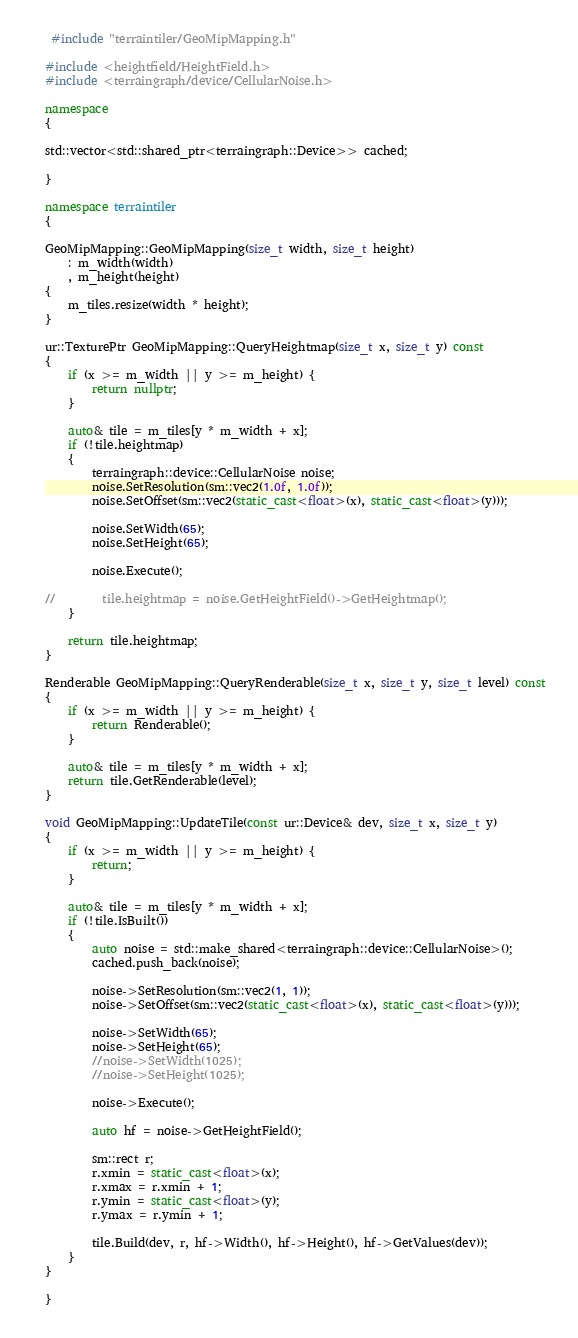<code> <loc_0><loc_0><loc_500><loc_500><_C++_> #include "terraintiler/GeoMipMapping.h"

#include <heightfield/HeightField.h>
#include <terraingraph/device/CellularNoise.h>

namespace
{

std::vector<std::shared_ptr<terraingraph::Device>> cached;

}

namespace terraintiler
{

GeoMipMapping::GeoMipMapping(size_t width, size_t height)
    : m_width(width)
    , m_height(height)
{
    m_tiles.resize(width * height);
}

ur::TexturePtr GeoMipMapping::QueryHeightmap(size_t x, size_t y) const
{
    if (x >= m_width || y >= m_height) {
        return nullptr;
    }

    auto& tile = m_tiles[y * m_width + x];
    if (!tile.heightmap)
    {
        terraingraph::device::CellularNoise noise;
        noise.SetResolution(sm::vec2(1.0f, 1.0f));
        noise.SetOffset(sm::vec2(static_cast<float>(x), static_cast<float>(y)));

        noise.SetWidth(65);
        noise.SetHeight(65);

        noise.Execute();

//        tile.heightmap = noise.GetHeightField()->GetHeightmap();
    }

    return tile.heightmap;
}

Renderable GeoMipMapping::QueryRenderable(size_t x, size_t y, size_t level) const
{
    if (x >= m_width || y >= m_height) {
        return Renderable();
    }

    auto& tile = m_tiles[y * m_width + x];
    return tile.GetRenderable(level);
}

void GeoMipMapping::UpdateTile(const ur::Device& dev, size_t x, size_t y)
{
    if (x >= m_width || y >= m_height) {
        return;
    }

    auto& tile = m_tiles[y * m_width + x];
    if (!tile.IsBuilt())
    {
        auto noise = std::make_shared<terraingraph::device::CellularNoise>();
        cached.push_back(noise);

        noise->SetResolution(sm::vec2(1, 1));
        noise->SetOffset(sm::vec2(static_cast<float>(x), static_cast<float>(y)));

        noise->SetWidth(65);
        noise->SetHeight(65);
        //noise->SetWidth(1025);
        //noise->SetHeight(1025);

        noise->Execute();

        auto hf = noise->GetHeightField();

        sm::rect r;
        r.xmin = static_cast<float>(x);
        r.xmax = r.xmin + 1;
        r.ymin = static_cast<float>(y);
        r.ymax = r.ymin + 1;

        tile.Build(dev, r, hf->Width(), hf->Height(), hf->GetValues(dev));
    }
}

}</code> 